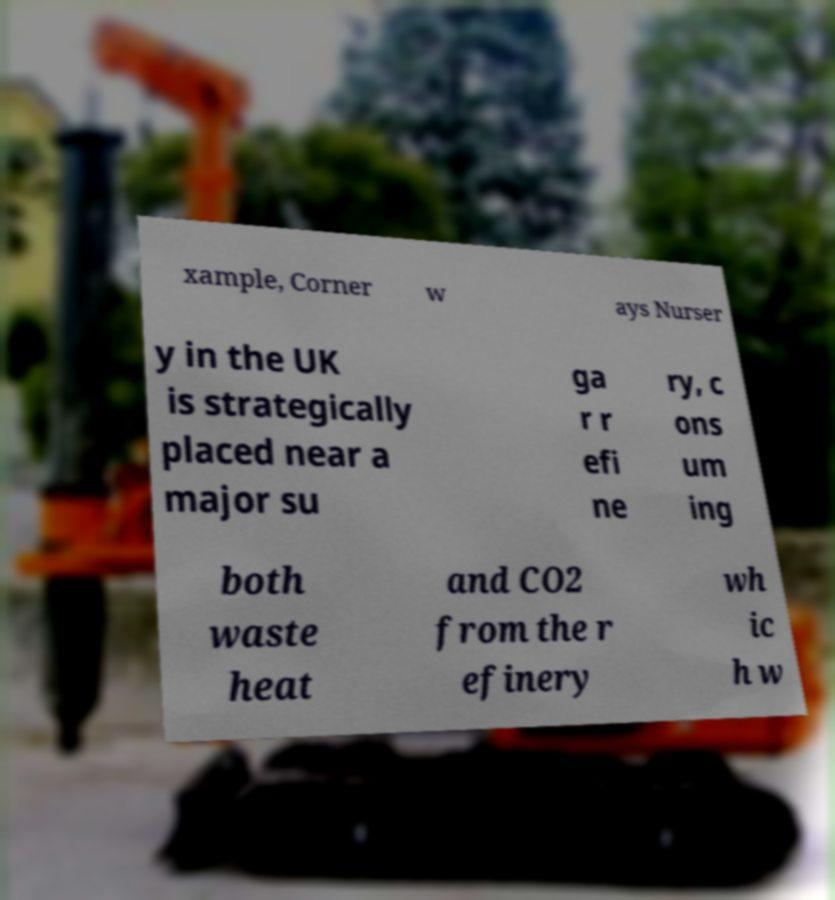Can you accurately transcribe the text from the provided image for me? xample, Corner w ays Nurser y in the UK is strategically placed near a major su ga r r efi ne ry, c ons um ing both waste heat and CO2 from the r efinery wh ic h w 